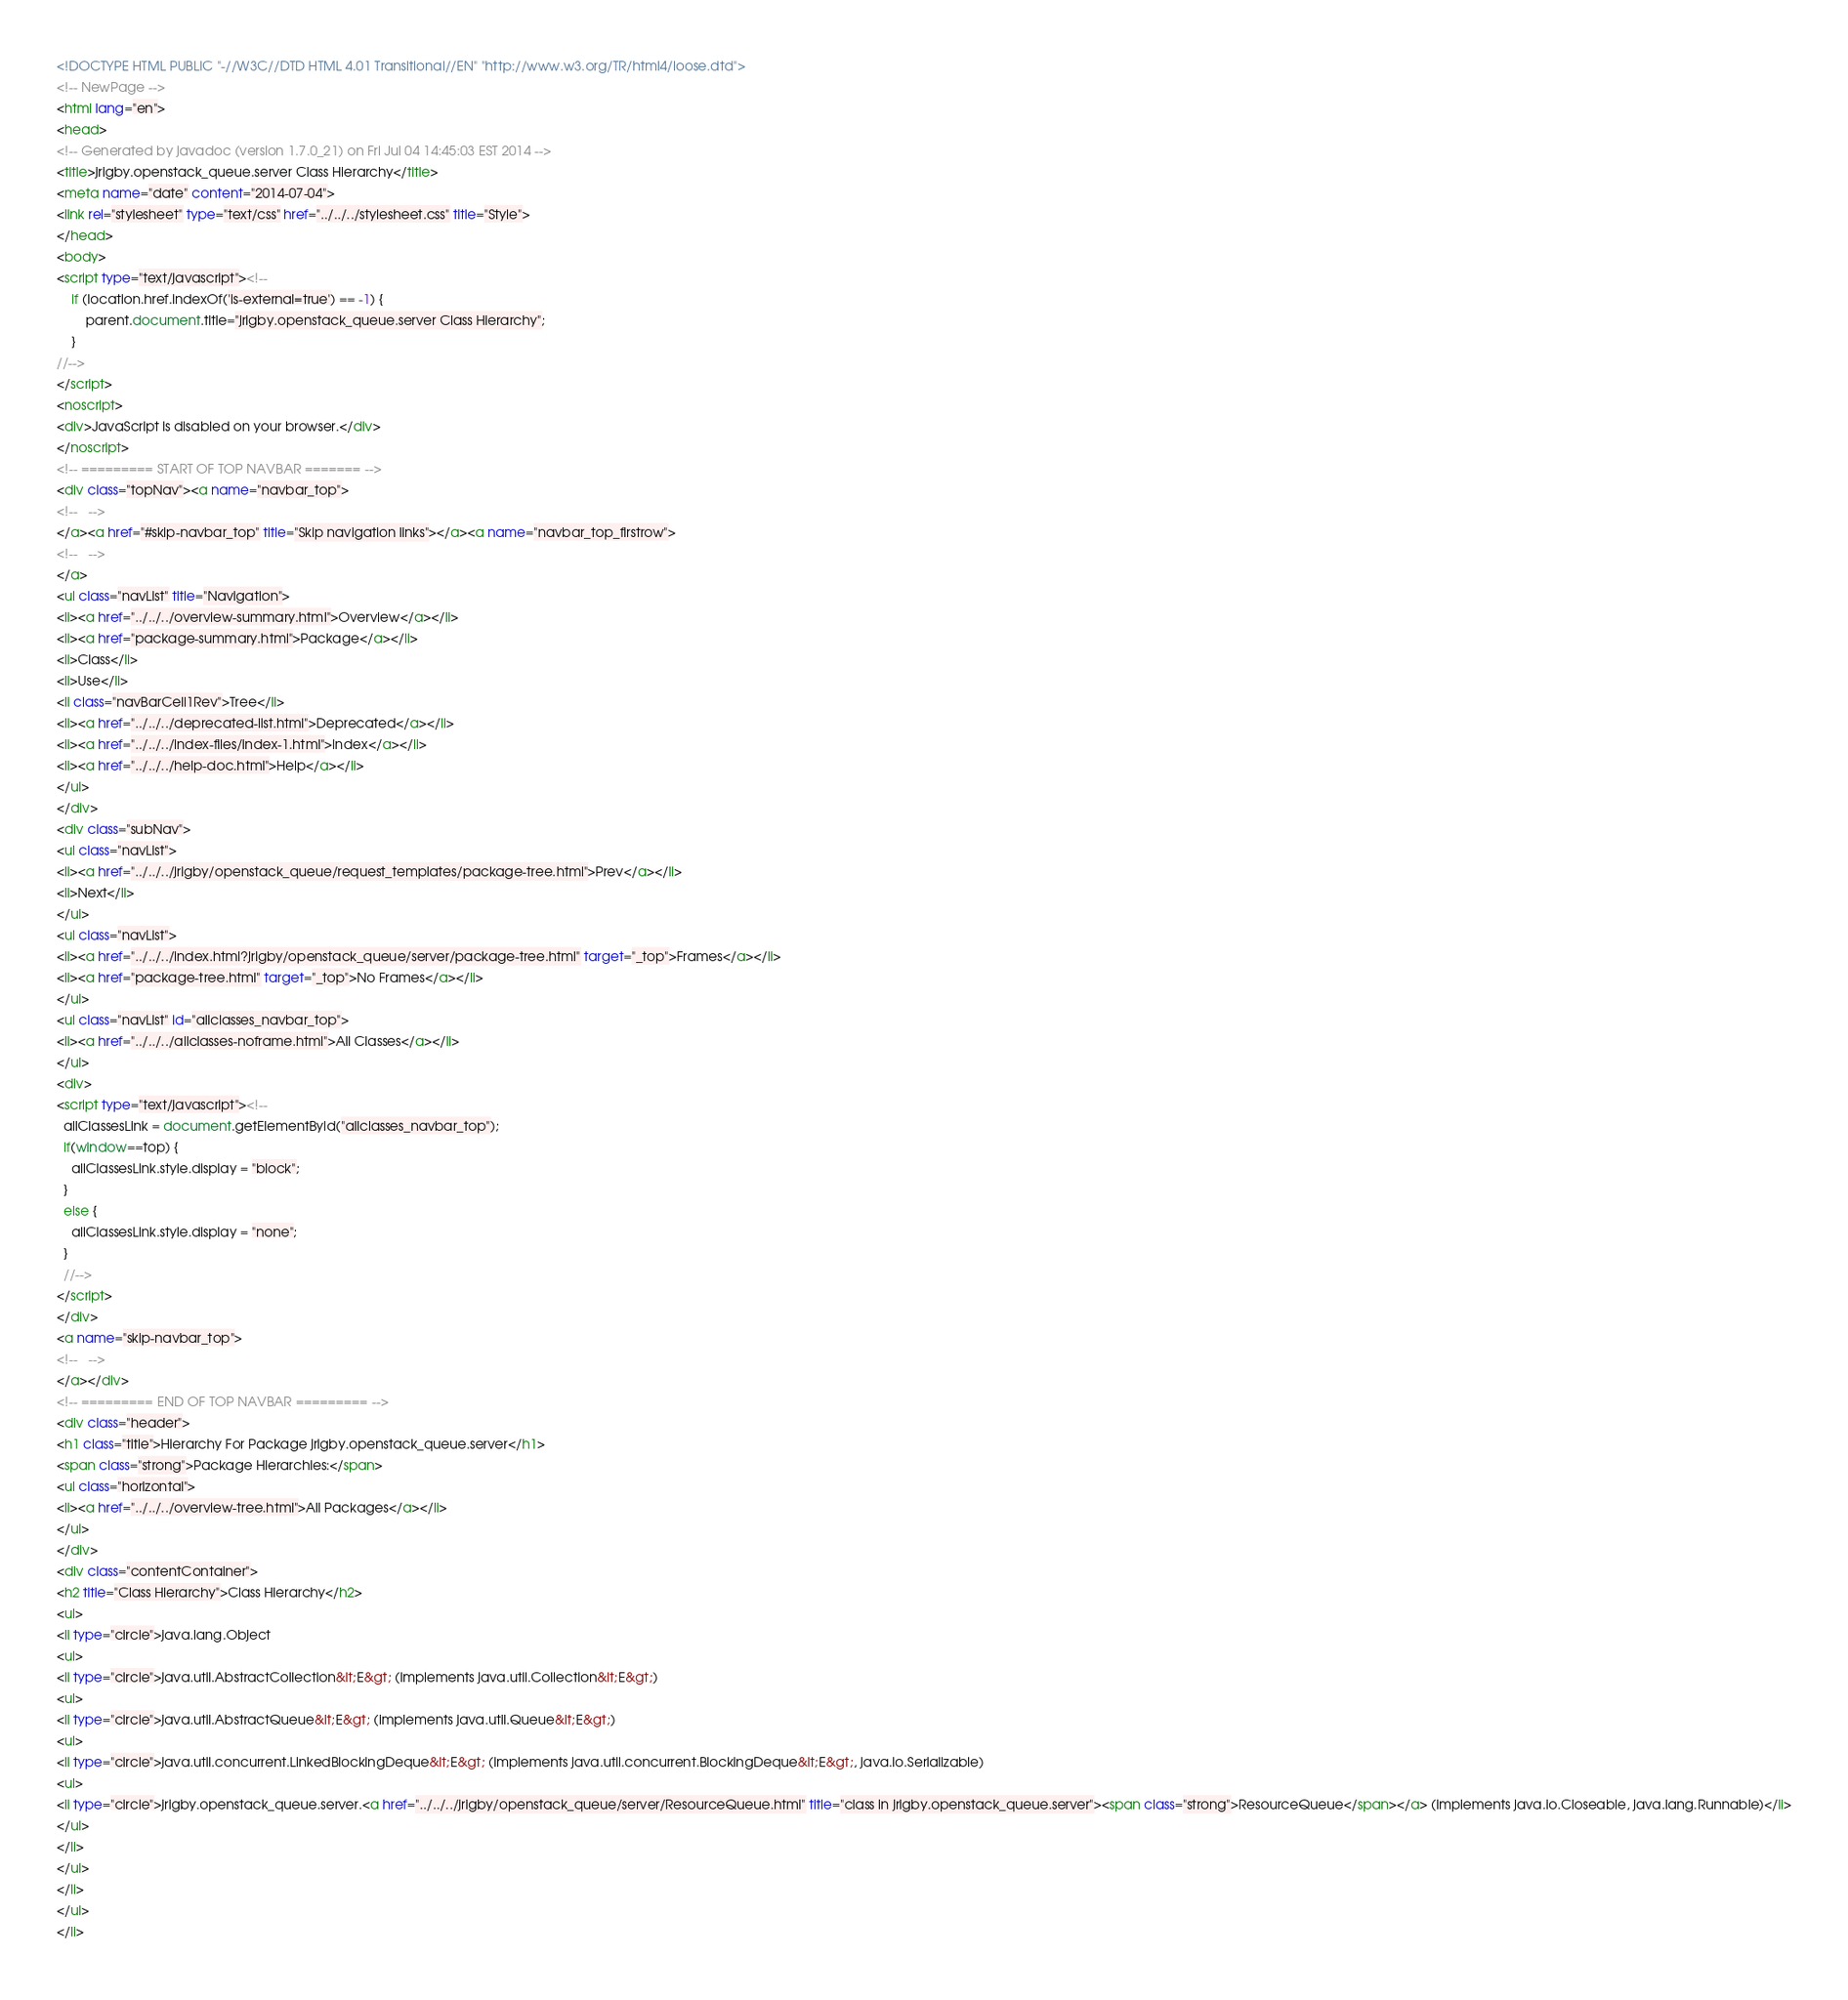<code> <loc_0><loc_0><loc_500><loc_500><_HTML_><!DOCTYPE HTML PUBLIC "-//W3C//DTD HTML 4.01 Transitional//EN" "http://www.w3.org/TR/html4/loose.dtd">
<!-- NewPage -->
<html lang="en">
<head>
<!-- Generated by javadoc (version 1.7.0_21) on Fri Jul 04 14:45:03 EST 2014 -->
<title>jrigby.openstack_queue.server Class Hierarchy</title>
<meta name="date" content="2014-07-04">
<link rel="stylesheet" type="text/css" href="../../../stylesheet.css" title="Style">
</head>
<body>
<script type="text/javascript"><!--
    if (location.href.indexOf('is-external=true') == -1) {
        parent.document.title="jrigby.openstack_queue.server Class Hierarchy";
    }
//-->
</script>
<noscript>
<div>JavaScript is disabled on your browser.</div>
</noscript>
<!-- ========= START OF TOP NAVBAR ======= -->
<div class="topNav"><a name="navbar_top">
<!--   -->
</a><a href="#skip-navbar_top" title="Skip navigation links"></a><a name="navbar_top_firstrow">
<!--   -->
</a>
<ul class="navList" title="Navigation">
<li><a href="../../../overview-summary.html">Overview</a></li>
<li><a href="package-summary.html">Package</a></li>
<li>Class</li>
<li>Use</li>
<li class="navBarCell1Rev">Tree</li>
<li><a href="../../../deprecated-list.html">Deprecated</a></li>
<li><a href="../../../index-files/index-1.html">Index</a></li>
<li><a href="../../../help-doc.html">Help</a></li>
</ul>
</div>
<div class="subNav">
<ul class="navList">
<li><a href="../../../jrigby/openstack_queue/request_templates/package-tree.html">Prev</a></li>
<li>Next</li>
</ul>
<ul class="navList">
<li><a href="../../../index.html?jrigby/openstack_queue/server/package-tree.html" target="_top">Frames</a></li>
<li><a href="package-tree.html" target="_top">No Frames</a></li>
</ul>
<ul class="navList" id="allclasses_navbar_top">
<li><a href="../../../allclasses-noframe.html">All Classes</a></li>
</ul>
<div>
<script type="text/javascript"><!--
  allClassesLink = document.getElementById("allclasses_navbar_top");
  if(window==top) {
    allClassesLink.style.display = "block";
  }
  else {
    allClassesLink.style.display = "none";
  }
  //-->
</script>
</div>
<a name="skip-navbar_top">
<!--   -->
</a></div>
<!-- ========= END OF TOP NAVBAR ========= -->
<div class="header">
<h1 class="title">Hierarchy For Package jrigby.openstack_queue.server</h1>
<span class="strong">Package Hierarchies:</span>
<ul class="horizontal">
<li><a href="../../../overview-tree.html">All Packages</a></li>
</ul>
</div>
<div class="contentContainer">
<h2 title="Class Hierarchy">Class Hierarchy</h2>
<ul>
<li type="circle">java.lang.Object
<ul>
<li type="circle">java.util.AbstractCollection&lt;E&gt; (implements java.util.Collection&lt;E&gt;)
<ul>
<li type="circle">java.util.AbstractQueue&lt;E&gt; (implements java.util.Queue&lt;E&gt;)
<ul>
<li type="circle">java.util.concurrent.LinkedBlockingDeque&lt;E&gt; (implements java.util.concurrent.BlockingDeque&lt;E&gt;, java.io.Serializable)
<ul>
<li type="circle">jrigby.openstack_queue.server.<a href="../../../jrigby/openstack_queue/server/ResourceQueue.html" title="class in jrigby.openstack_queue.server"><span class="strong">ResourceQueue</span></a> (implements java.io.Closeable, java.lang.Runnable)</li>
</ul>
</li>
</ul>
</li>
</ul>
</li></code> 